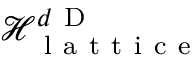<formula> <loc_0><loc_0><loc_500><loc_500>\mathcal { H } _ { l a t t i c e } ^ { d D }</formula> 